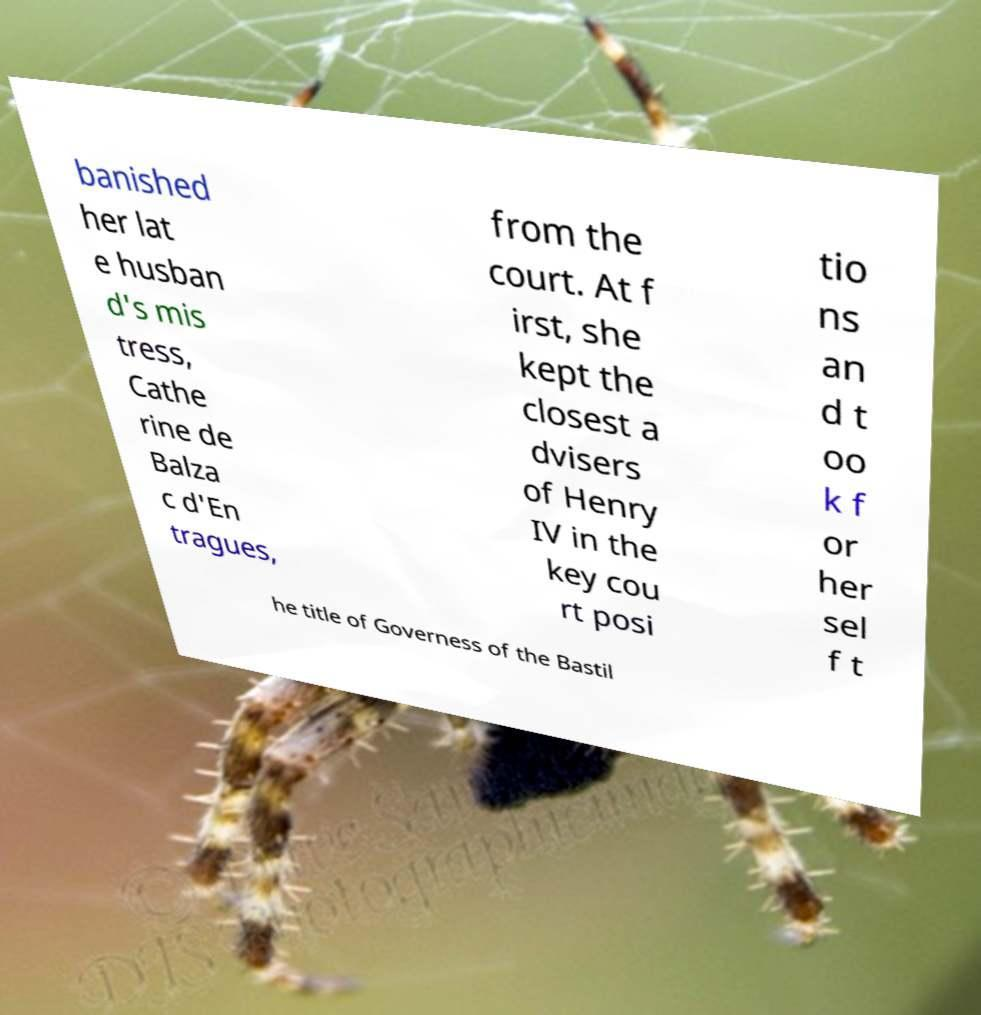What messages or text are displayed in this image? I need them in a readable, typed format. banished her lat e husban d's mis tress, Cathe rine de Balza c d'En tragues, from the court. At f irst, she kept the closest a dvisers of Henry IV in the key cou rt posi tio ns an d t oo k f or her sel f t he title of Governess of the Bastil 